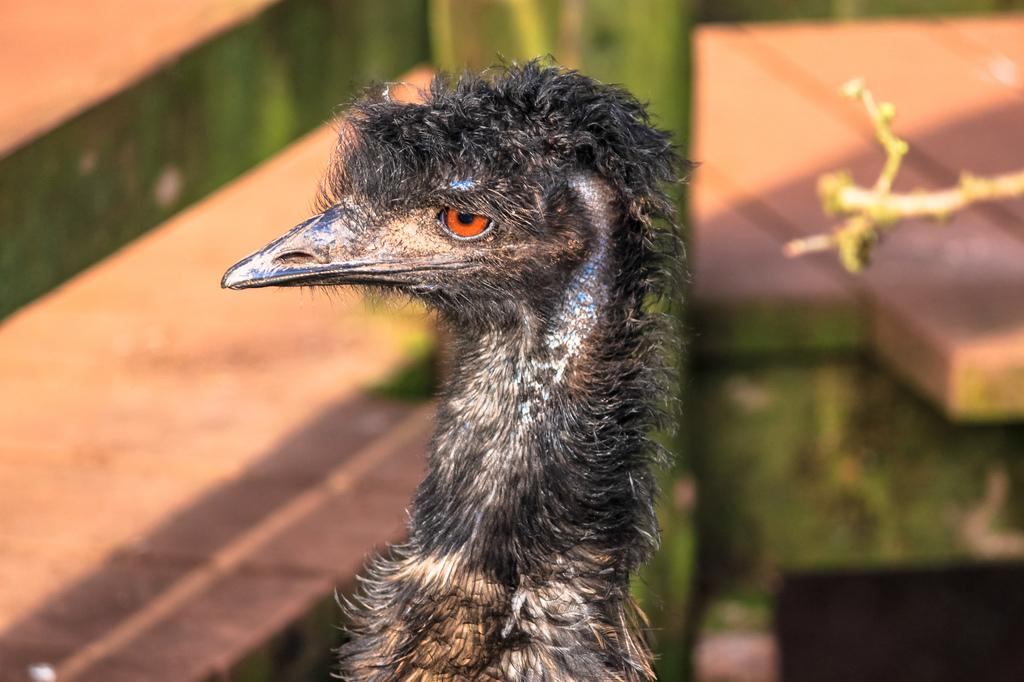What type of animal can be seen in the image? There is a bird in the image. What type of vegetation is visible in the image? There is grass visible in the image. What type of structure is present in the image? There is a fence in the image. Can you determine the time of day the image was taken? The image was likely taken during the day, as there is sufficient light to see the bird, grass, and fence clearly. What type of shoe is the bird wearing in the image? There is no shoe present in the image, as birds do not wear shoes. 